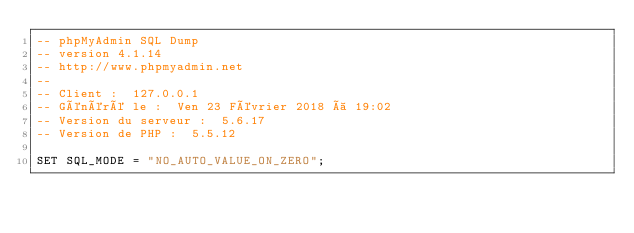Convert code to text. <code><loc_0><loc_0><loc_500><loc_500><_SQL_>-- phpMyAdmin SQL Dump
-- version 4.1.14
-- http://www.phpmyadmin.net
--
-- Client :  127.0.0.1
-- Généré le :  Ven 23 Février 2018 à 19:02
-- Version du serveur :  5.6.17
-- Version de PHP :  5.5.12

SET SQL_MODE = "NO_AUTO_VALUE_ON_ZERO";</code> 